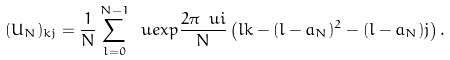Convert formula to latex. <formula><loc_0><loc_0><loc_500><loc_500>( U _ { N } ) _ { k j } = \frac { 1 } { N } \sum _ { l = 0 } ^ { N - 1 } \ u e x p { \frac { 2 \pi \ u i } { N } \left ( l k - ( l - a _ { N } ) ^ { 2 } - ( l - a _ { N } ) j \right ) } \, .</formula> 